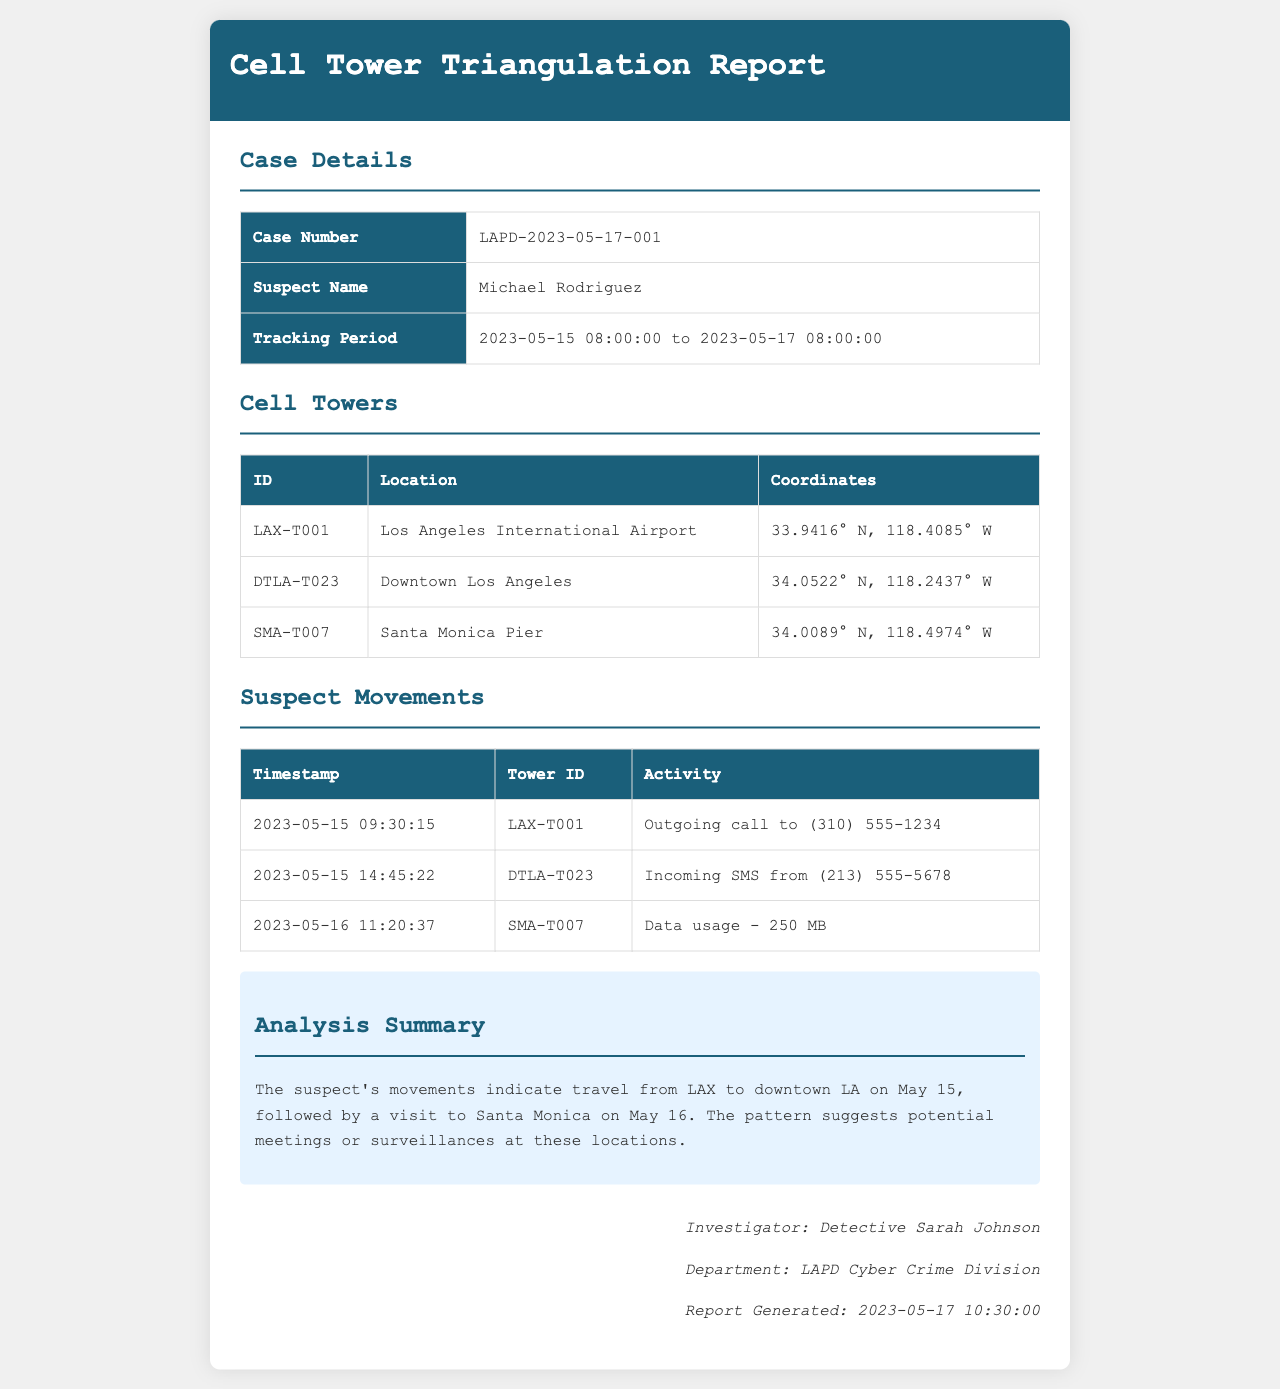What is the case number? The case number is specified in the case details section of the document.
Answer: LAPD-2023-05-17-001 Who is the suspect? The suspect's name is provided in the case details section.
Answer: Michael Rodriguez What is the tracking period? The tracking period specifies the start and end timestamps of the data collected.
Answer: 2023-05-15 08:00:00 to 2023-05-17 08:00:00 What tower ID was used during the outgoing call? The outgoing call was made from a specific tower identified in the suspect movements section.
Answer: LAX-T001 What significant location did the suspect visit after LAX? The movements indicate travel to a specific location after the initial position.
Answer: Downtown Los Angeles What type of activity occurred at Santa Monica Pier? The document includes a specific activity type that occurred at this location.
Answer: Data usage - 250 MB How many cell towers are listed in the report? The total number of unique cell towers is mentioned in the Cell Towers section.
Answer: 3 What is the name of the investigator? The investigator's name is included in the footer of the document.
Answer: Detective Sarah Johnson When was the report generated? The date and time of report generation are mentioned in the footer.
Answer: 2023-05-17 10:30:00 